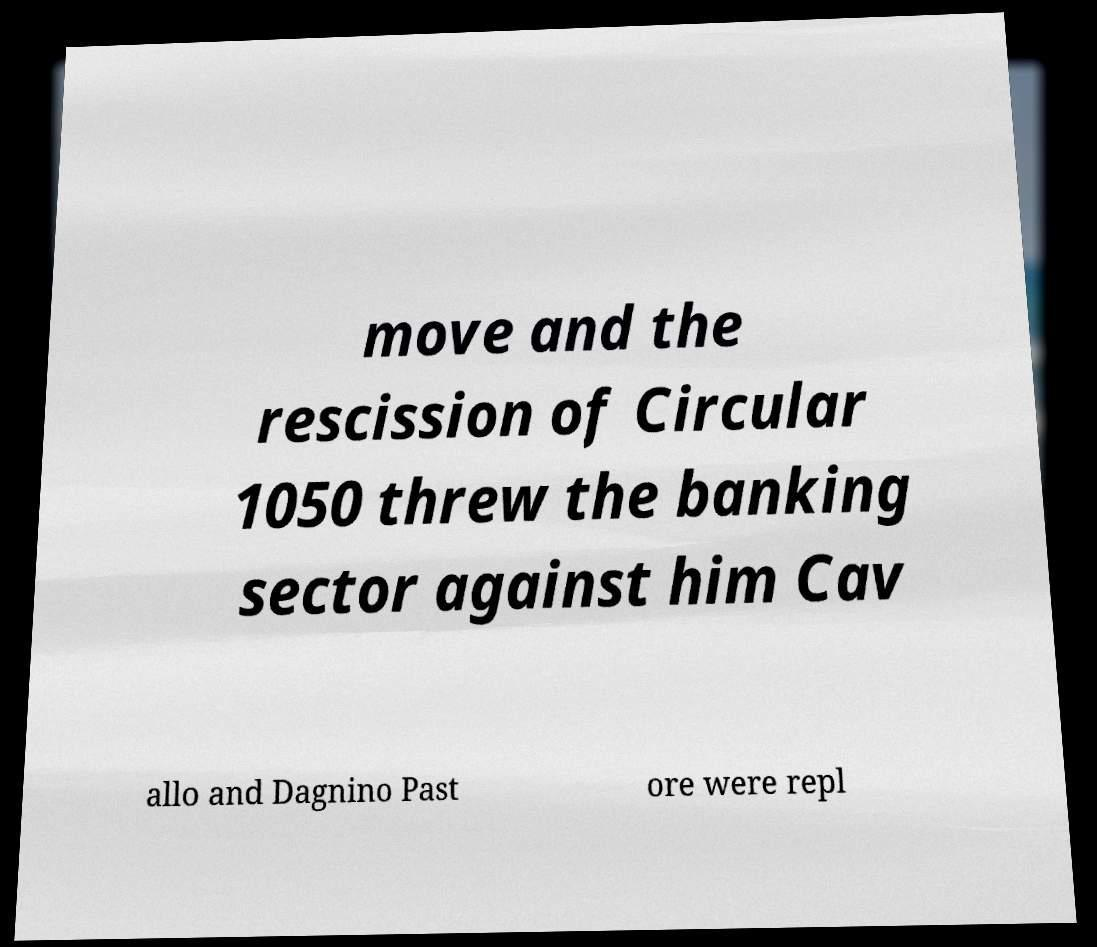Please read and relay the text visible in this image. What does it say? move and the rescission of Circular 1050 threw the banking sector against him Cav allo and Dagnino Past ore were repl 